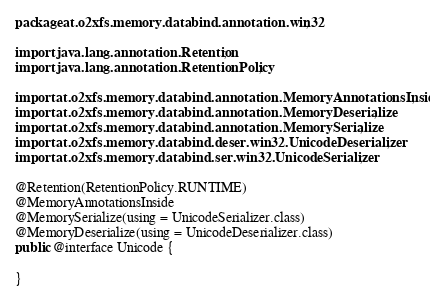<code> <loc_0><loc_0><loc_500><loc_500><_Java_>package at.o2xfs.memory.databind.annotation.win32;

import java.lang.annotation.Retention;
import java.lang.annotation.RetentionPolicy;

import at.o2xfs.memory.databind.annotation.MemoryAnnotationsInside;
import at.o2xfs.memory.databind.annotation.MemoryDeserialize;
import at.o2xfs.memory.databind.annotation.MemorySerialize;
import at.o2xfs.memory.databind.deser.win32.UnicodeDeserializer;
import at.o2xfs.memory.databind.ser.win32.UnicodeSerializer;

@Retention(RetentionPolicy.RUNTIME)
@MemoryAnnotationsInside
@MemorySerialize(using = UnicodeSerializer.class)
@MemoryDeserialize(using = UnicodeDeserializer.class)
public @interface Unicode {

}
</code> 